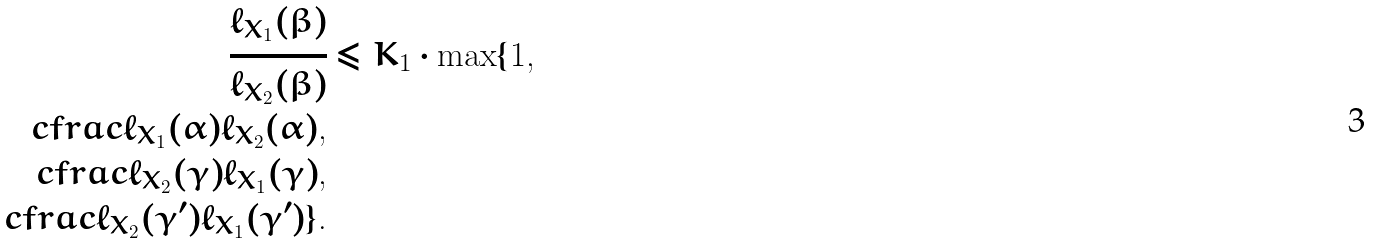Convert formula to latex. <formula><loc_0><loc_0><loc_500><loc_500>\cfrac { \ell _ { X _ { 1 } } ( \beta ) } { \ell _ { X _ { 2 } } ( \beta ) } & \leq K _ { 1 } \cdot \max \{ 1 , \\ c f r a c { \ell _ { X _ { 1 } } ( \alpha ) } { \ell _ { X _ { 2 } } ( \alpha ) } , \\ c f r a c { \ell _ { X _ { 2 } } ( \gamma ) } { \ell _ { X _ { 1 } } ( \gamma ) } , \\ c f r a c { \ell _ { X _ { 2 } } ( \gamma ^ { \prime } ) } { \ell _ { X _ { 1 } } ( \gamma ^ { \prime } ) } \} .</formula> 